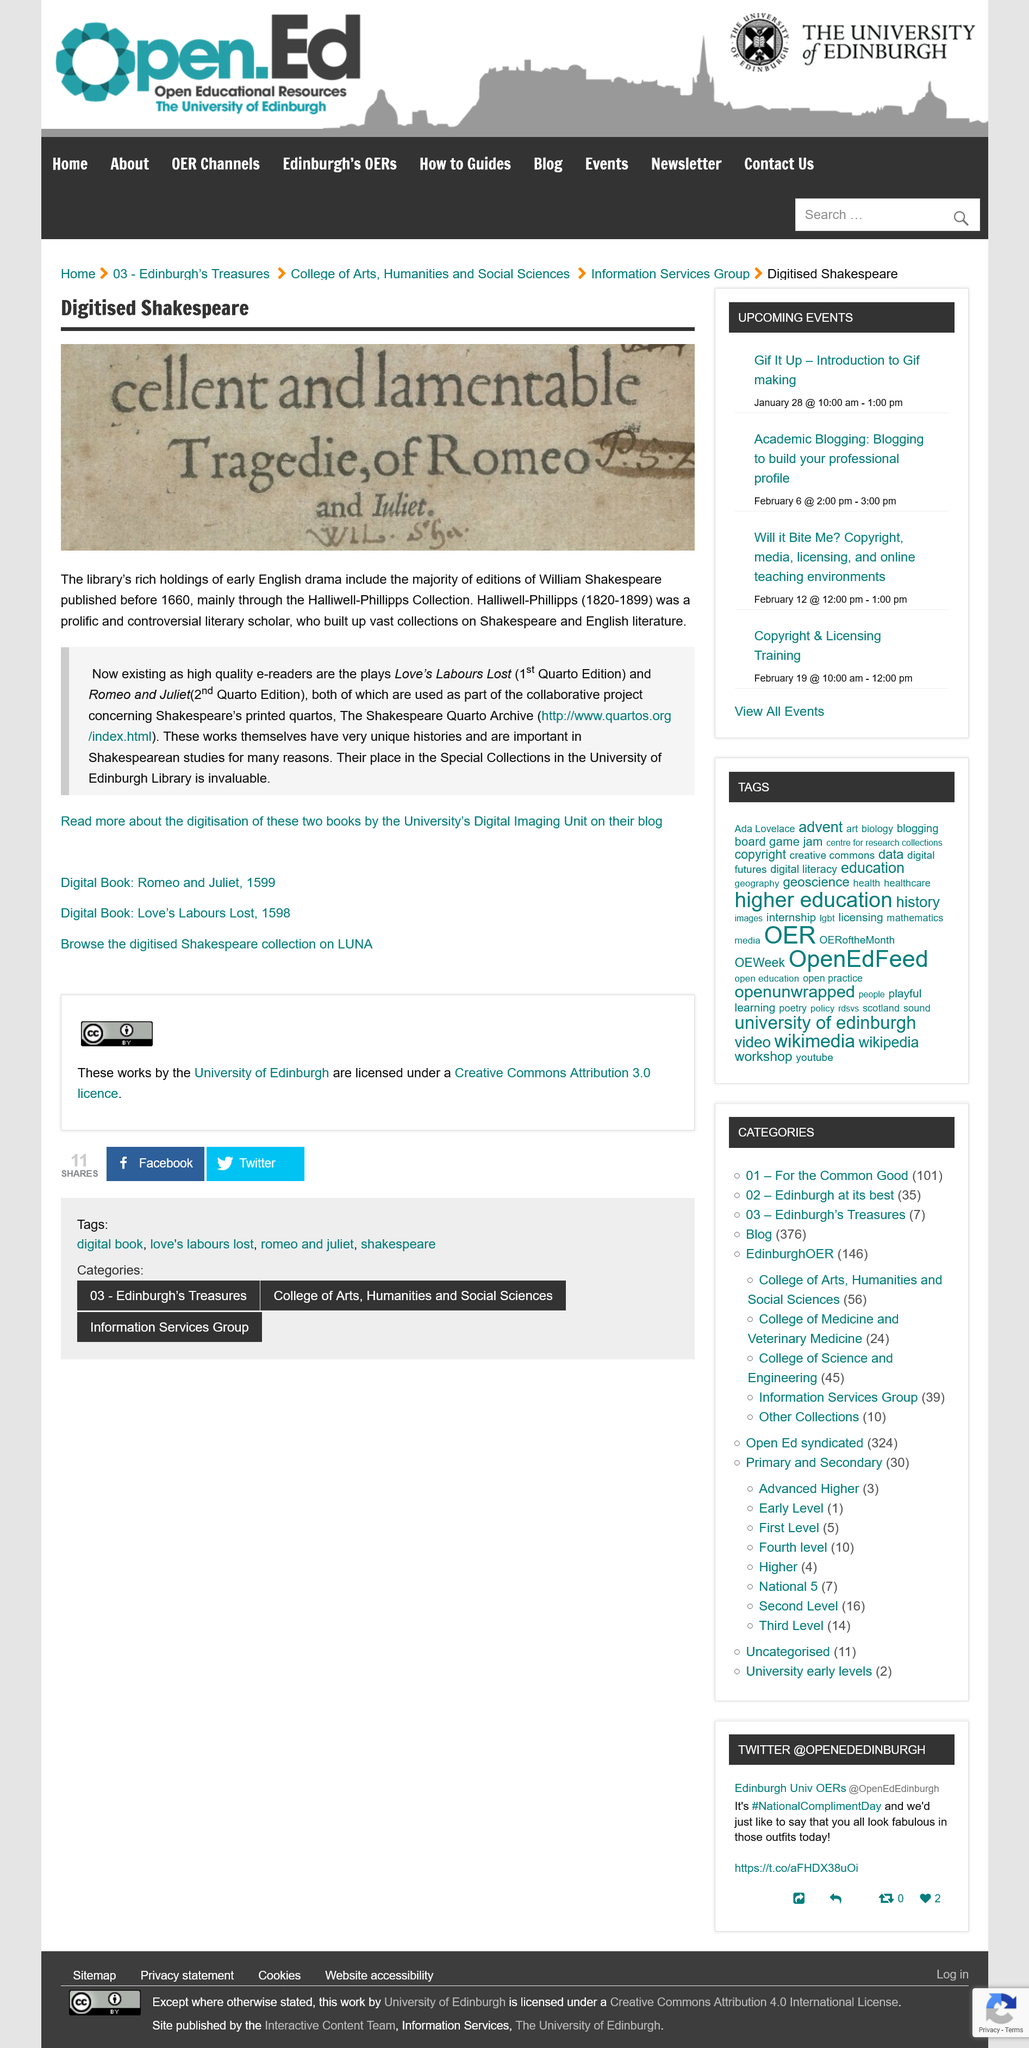Indicate a few pertinent items in this graphic. The topic of digitized Shakespeare is the conversion of Shakespeare's works from physical copies to digital versions. The majority of editions of William Shakespeare's works were published before 1660. The play mentioned is Romeo and Juliet. 